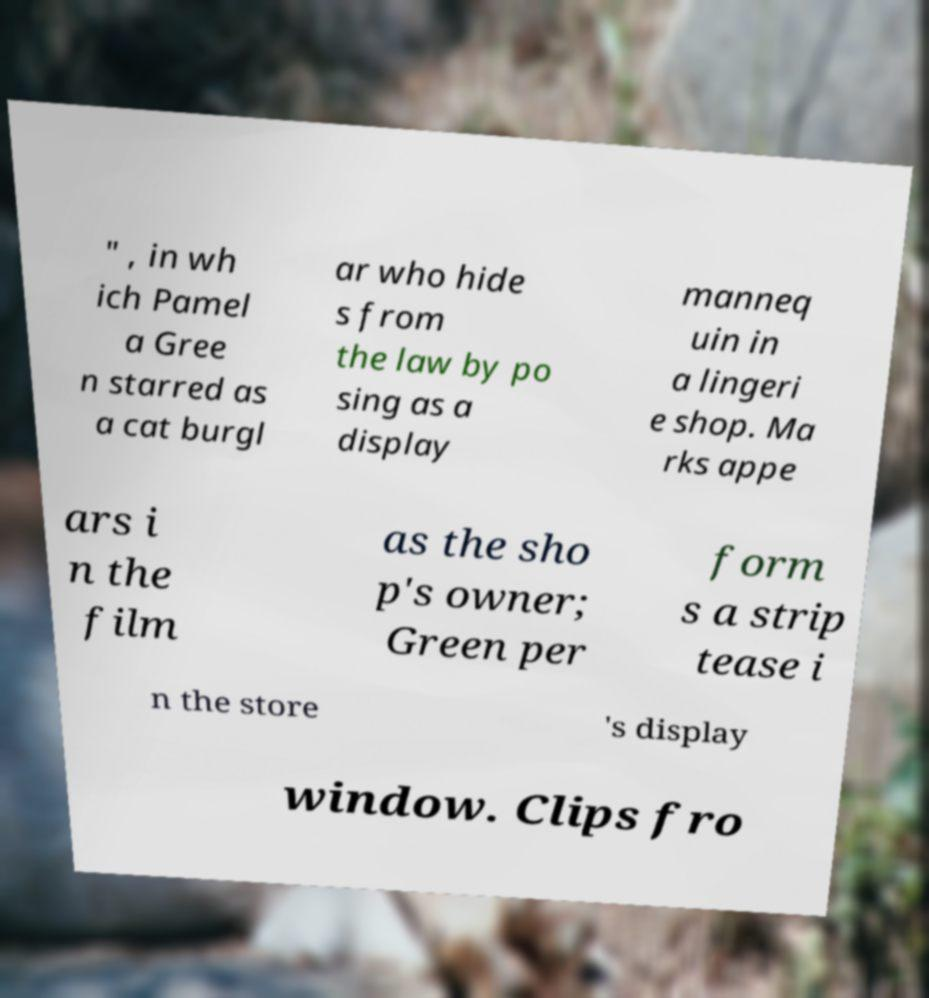Can you read and provide the text displayed in the image?This photo seems to have some interesting text. Can you extract and type it out for me? " , in wh ich Pamel a Gree n starred as a cat burgl ar who hide s from the law by po sing as a display manneq uin in a lingeri e shop. Ma rks appe ars i n the film as the sho p's owner; Green per form s a strip tease i n the store 's display window. Clips fro 